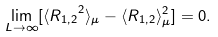Convert formula to latex. <formula><loc_0><loc_0><loc_500><loc_500>\lim _ { L \rightarrow \infty } [ \langle { R _ { 1 , 2 } } ^ { 2 } \rangle _ { \mu } - \langle R _ { 1 , 2 } \rangle _ { \mu } ^ { 2 } ] = 0 .</formula> 